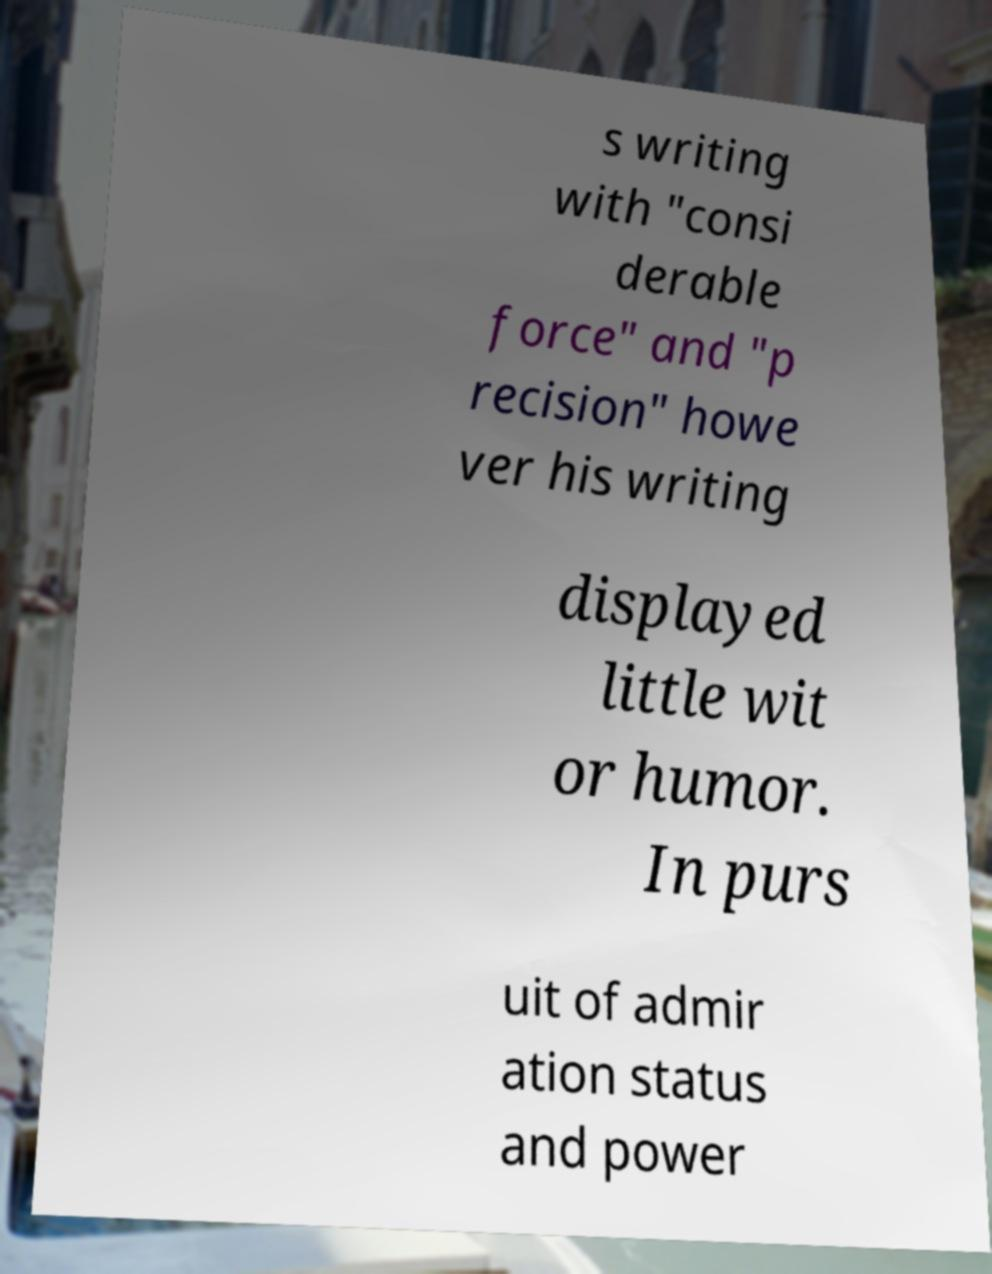I need the written content from this picture converted into text. Can you do that? s writing with "consi derable force" and "p recision" howe ver his writing displayed little wit or humor. In purs uit of admir ation status and power 